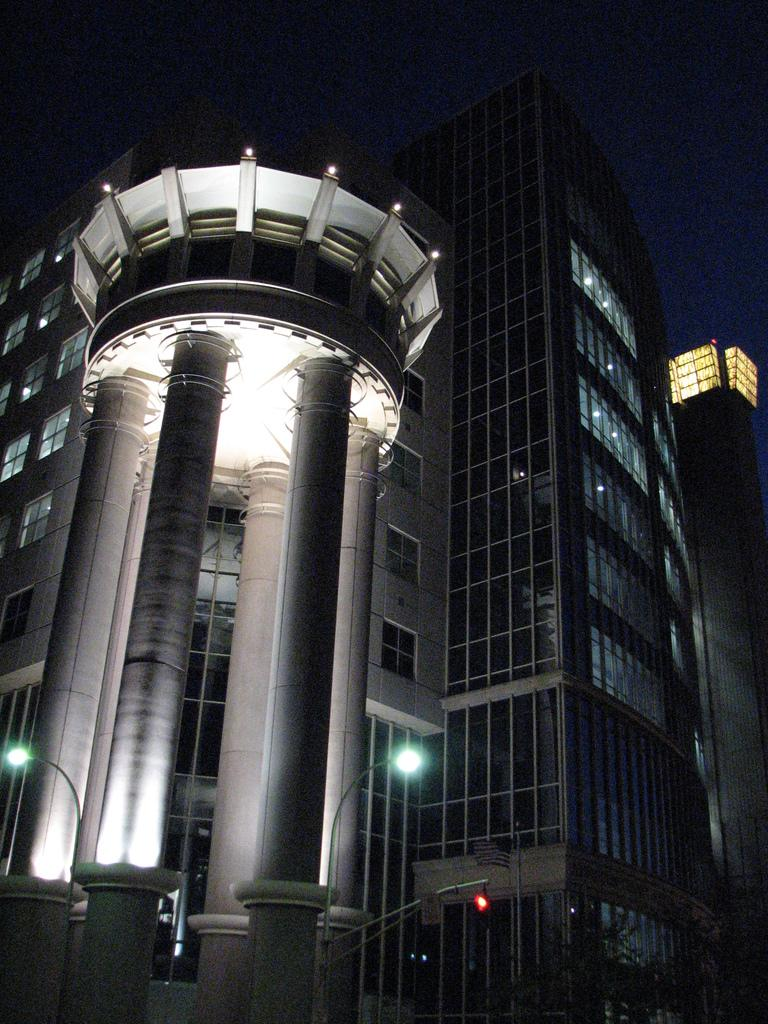What can be seen in the foreground of the picture? In the foreground of the picture, there are lights, a gate, and a wall. What is located in the center of the picture? In the center of the picture, there are buildings and lights. What is the condition of the top part of the image? The top part of the image is dark. Can you hear the sheep coughing in the image? There are no sheep or any indication of coughing in the image. Is there a bit of food visible in the image? There is no food or any reference to a bit in the image. 